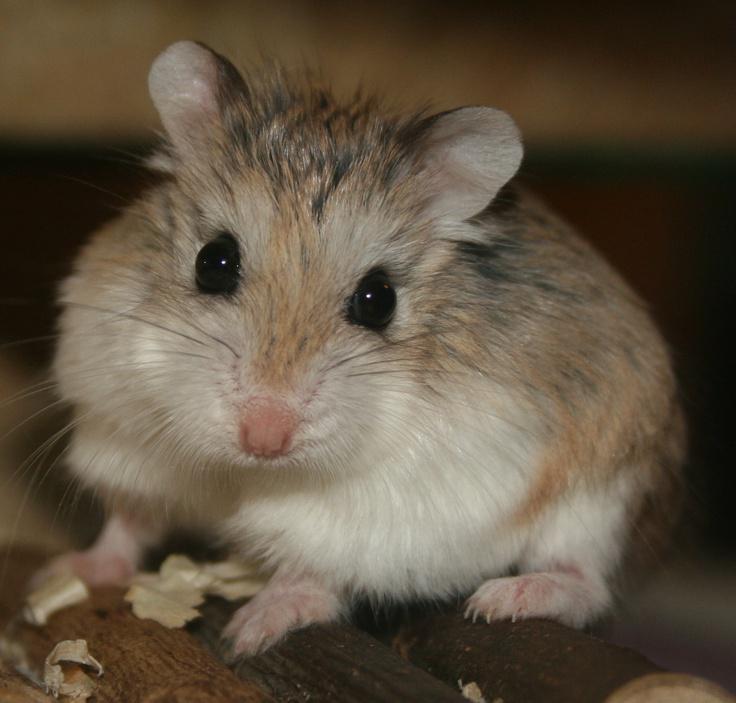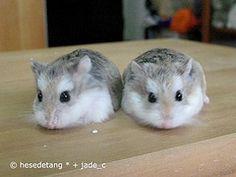The first image is the image on the left, the second image is the image on the right. Analyze the images presented: Is the assertion "At least one hamster is sitting on wood shavings." valid? Answer yes or no. No. The first image is the image on the left, the second image is the image on the right. For the images shown, is this caption "The image pair contains one hamster in the left image and two hamsters in the right image." true? Answer yes or no. Yes. 